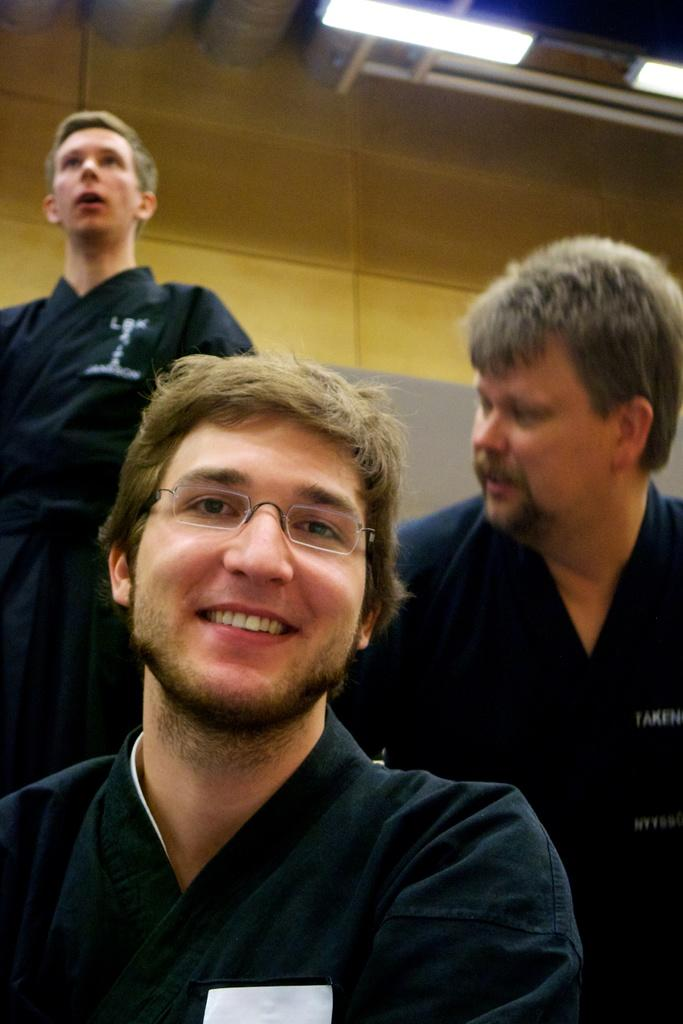What is the main subject of the image? The main subject of the image is a man. Can you describe the man's appearance? The man is wearing glasses and smiling. Are there any other people in the image? Yes, there are two persons in the background of the image. What can be seen in the background of the image? There is a wall and lights attached to the ceiling in the image. What type of bean is being used in the battle depicted in the image? There is no bean or battle present in the image; it features a man wearing glasses and smiling, with two persons and a wall in the background. Can you tell me how many skateboards are visible in the image? There are no skateboards present in the image. 